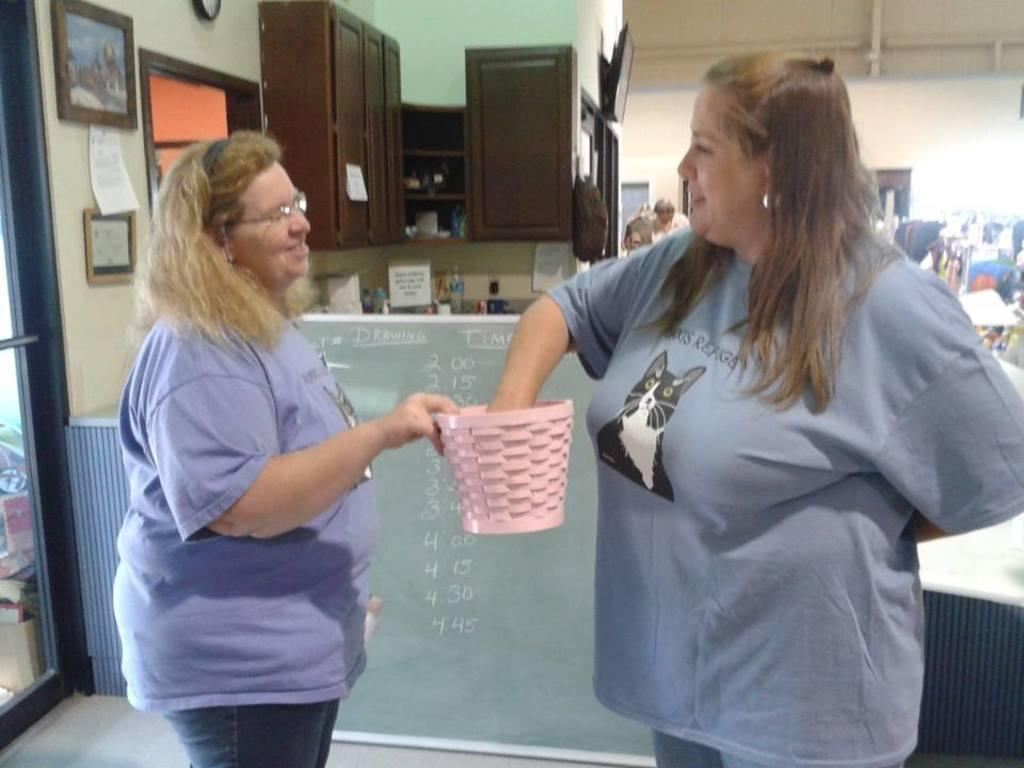What type of structure can be seen in the image? There is a wall in the image. What is hanging on the wall? There is a photo frame in the image. What type of furniture is present in the image? There are cupboards in the image. How many people are visible in the image? Two people are standing in the front of the image. What type of dinosaurs can be seen in the image? There are no dinosaurs present in the image. What is the desire of the people in the image? The image does not provide information about the desires of the people; it only shows them standing in front of the wall. 